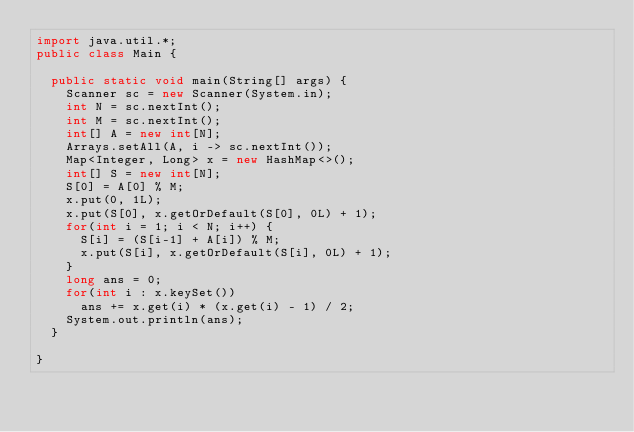Convert code to text. <code><loc_0><loc_0><loc_500><loc_500><_Java_>import java.util.*;
public class Main {

	public static void main(String[] args) {
		Scanner sc = new Scanner(System.in);
		int N = sc.nextInt();
		int M = sc.nextInt();
		int[] A = new int[N];
		Arrays.setAll(A, i -> sc.nextInt());
		Map<Integer, Long> x = new HashMap<>();
		int[] S = new int[N];
		S[0] = A[0] % M;
		x.put(0, 1L);
		x.put(S[0], x.getOrDefault(S[0], 0L) + 1);
		for(int i = 1; i < N; i++) {
			S[i] = (S[i-1] + A[i]) % M;
			x.put(S[i], x.getOrDefault(S[i], 0L) + 1);
		}
		long ans = 0;
		for(int i : x.keySet())
			ans += x.get(i) * (x.get(i) - 1) / 2;
		System.out.println(ans);
	}

}</code> 